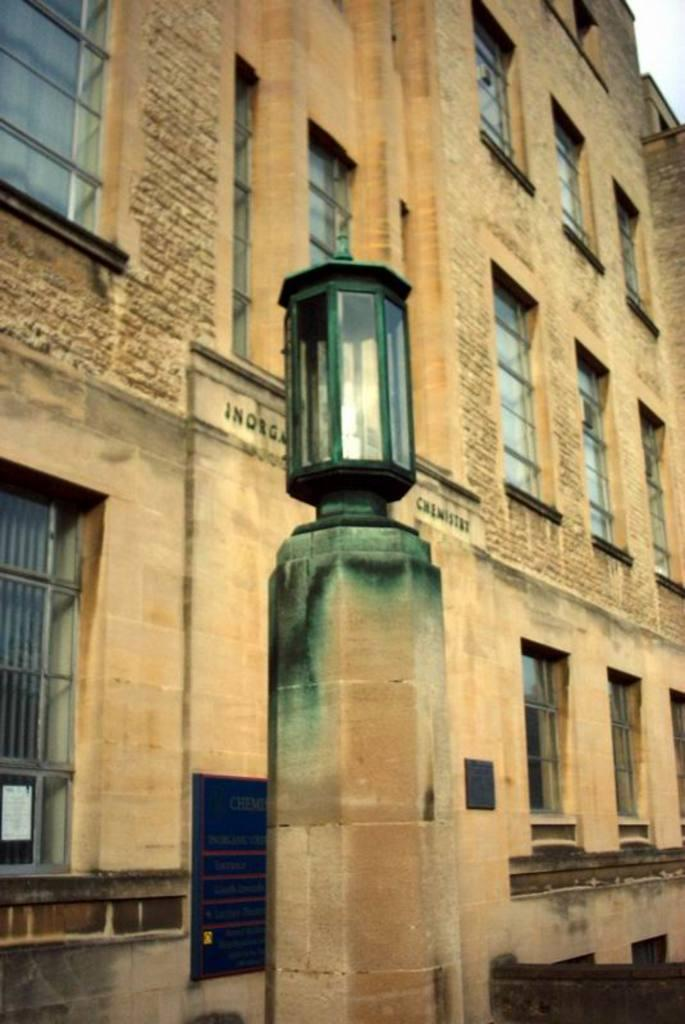What type of structure is the main subject of the image? There is a big building in the image. What can be observed about the building's appearance? The building has a lot of windows and is cream-colored. Can you describe any additional features in front of the building? There is a light fixed on a cement pole in front of the building. How many visitors are currently inside the building in the image? There is no information about visitors inside the building in the image. What type of appliance can be seen on the roof of the building? There is no appliance visible on the roof of the building in the image. 